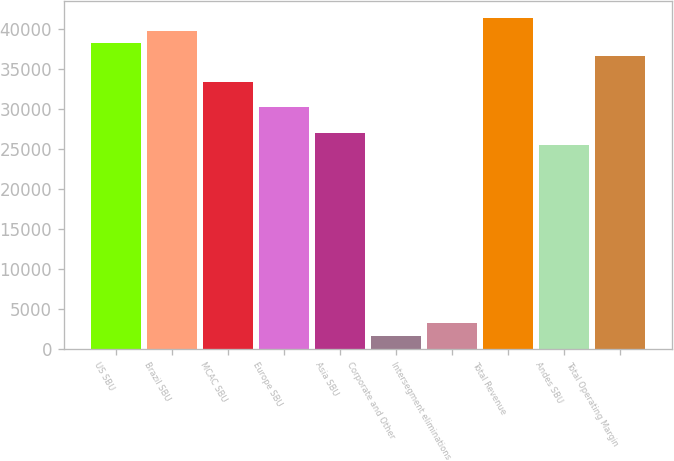<chart> <loc_0><loc_0><loc_500><loc_500><bar_chart><fcel>US SBU<fcel>Brazil SBU<fcel>MCAC SBU<fcel>Europe SBU<fcel>Asia SBU<fcel>Corporate and Other<fcel>Intersegment eliminations<fcel>Total Revenue<fcel>Andes SBU<fcel>Total Operating Margin<nl><fcel>38138.1<fcel>39727.2<fcel>33370.8<fcel>30192.7<fcel>27014.5<fcel>1589.25<fcel>3178.33<fcel>41316.2<fcel>25425.5<fcel>36549<nl></chart> 